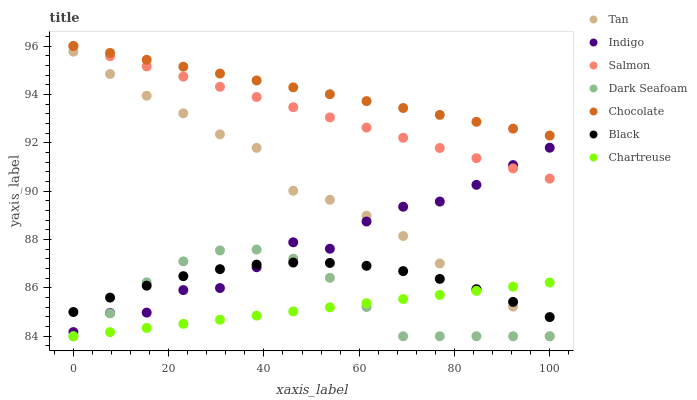Does Chartreuse have the minimum area under the curve?
Answer yes or no. Yes. Does Chocolate have the maximum area under the curve?
Answer yes or no. Yes. Does Salmon have the minimum area under the curve?
Answer yes or no. No. Does Salmon have the maximum area under the curve?
Answer yes or no. No. Is Chocolate the smoothest?
Answer yes or no. Yes. Is Indigo the roughest?
Answer yes or no. Yes. Is Salmon the smoothest?
Answer yes or no. No. Is Salmon the roughest?
Answer yes or no. No. Does Chartreuse have the lowest value?
Answer yes or no. Yes. Does Salmon have the lowest value?
Answer yes or no. No. Does Chocolate have the highest value?
Answer yes or no. Yes. Does Chartreuse have the highest value?
Answer yes or no. No. Is Dark Seafoam less than Chocolate?
Answer yes or no. Yes. Is Salmon greater than Dark Seafoam?
Answer yes or no. Yes. Does Chartreuse intersect Black?
Answer yes or no. Yes. Is Chartreuse less than Black?
Answer yes or no. No. Is Chartreuse greater than Black?
Answer yes or no. No. Does Dark Seafoam intersect Chocolate?
Answer yes or no. No. 